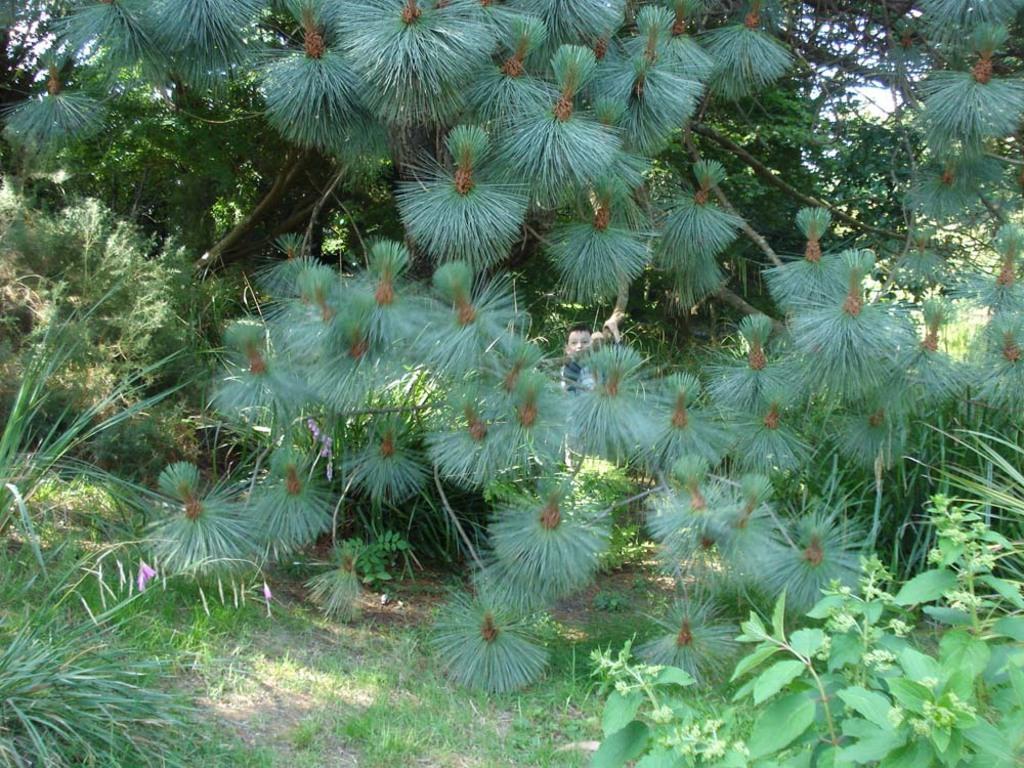Could you give a brief overview of what you see in this image? This image consists of many plants and trees. In the middle, there is a boy. At the bottom, there is grass. 